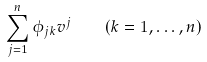Convert formula to latex. <formula><loc_0><loc_0><loc_500><loc_500>\sum _ { j = 1 } ^ { n } \phi _ { j k } v ^ { j } \quad ( k = 1 , \dots , n )</formula> 